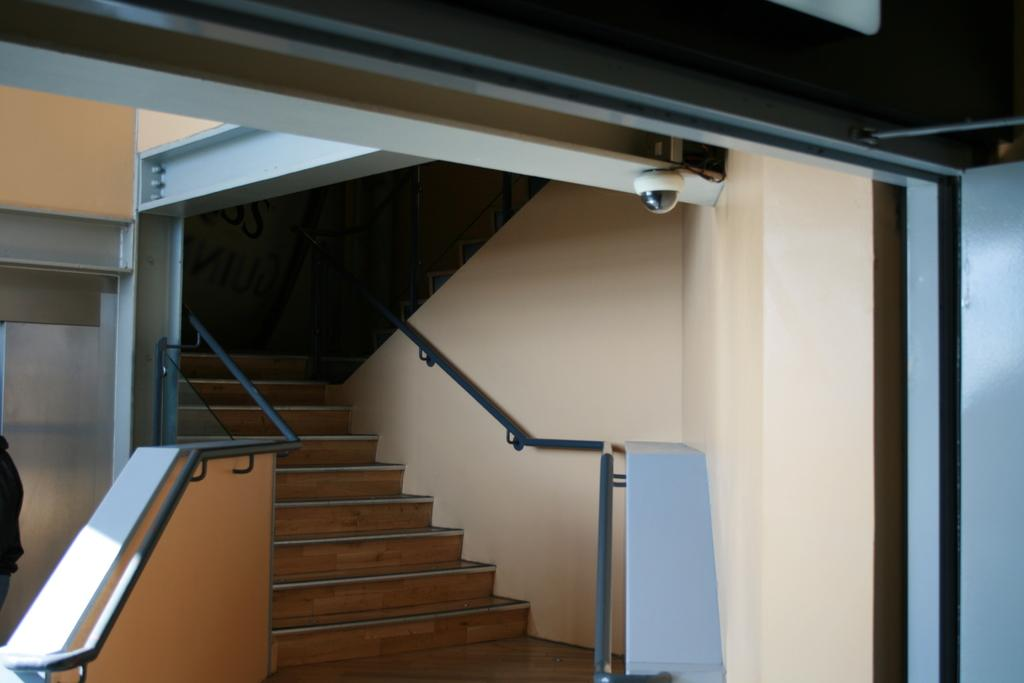What type of architectural feature is present in the image? There are steps in the image. What material is used for the rods in the image? The rods in the image are made of metal. What device is present to monitor the area in the image? There is a security camera in the image. Can you describe the person in the image? There is a person on the left side of the image. What type of surprise is being covered by the gate in the image? There is no gate present in the image, and therefore no surprise being covered. What type of gate is visible in the image? There is no gate present in the image. 